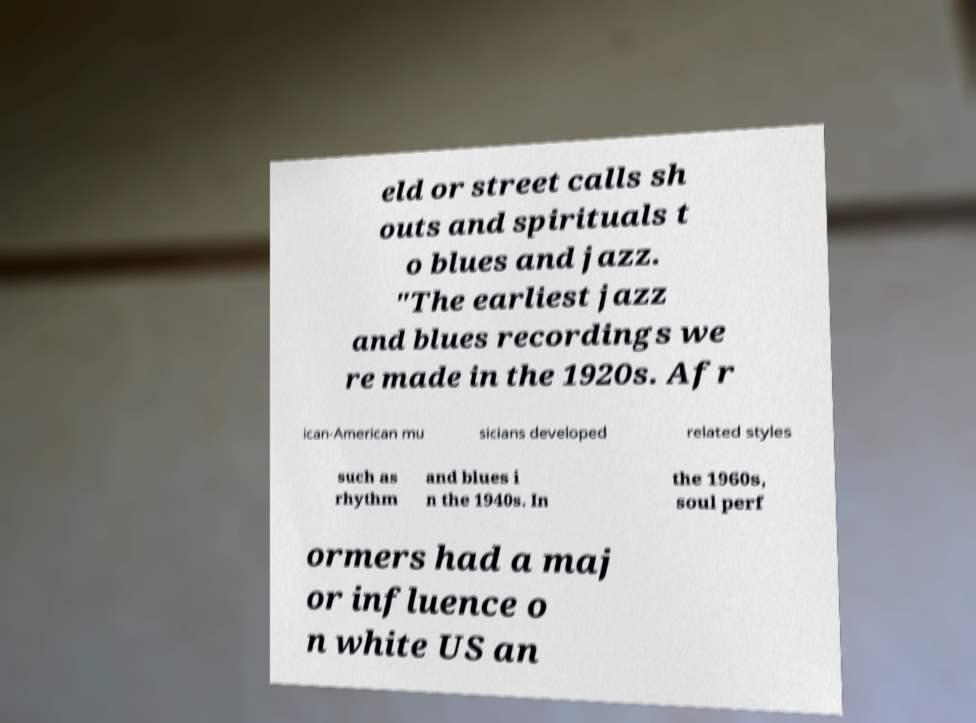Please identify and transcribe the text found in this image. eld or street calls sh outs and spirituals t o blues and jazz. "The earliest jazz and blues recordings we re made in the 1920s. Afr ican-American mu sicians developed related styles such as rhythm and blues i n the 1940s. In the 1960s, soul perf ormers had a maj or influence o n white US an 